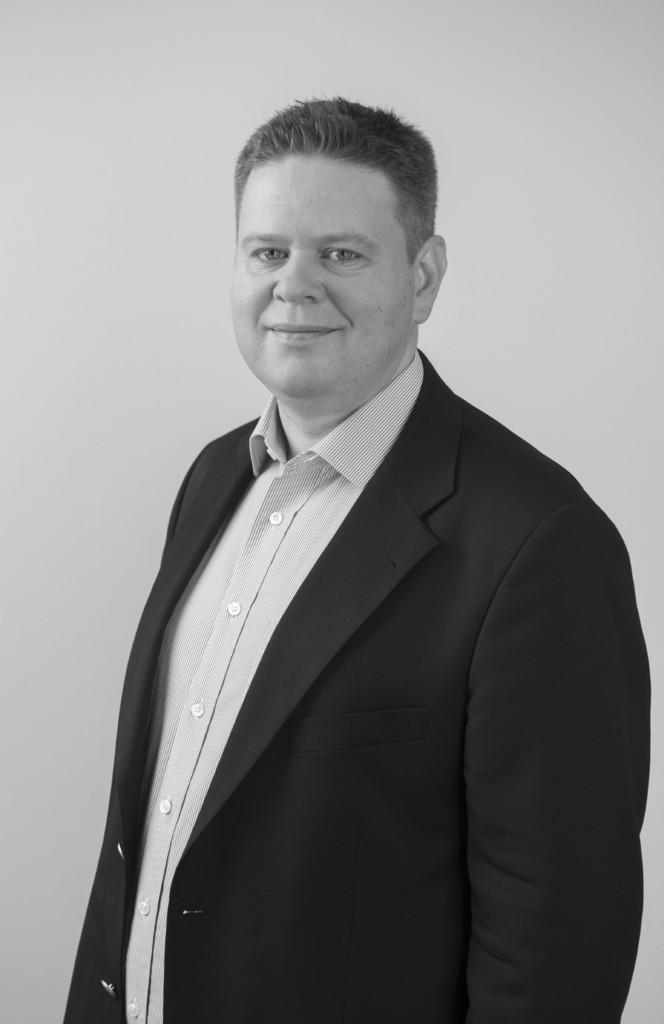What is the main subject of the image? There is a man in the image. What is the man doing in the image? The man is standing in the image. What is the man's facial expression in the image? The man is smiling in the image. What type of bit is the man holding in his hand in the image? There is no bit present in the image, and the man is not holding anything in his hand. 